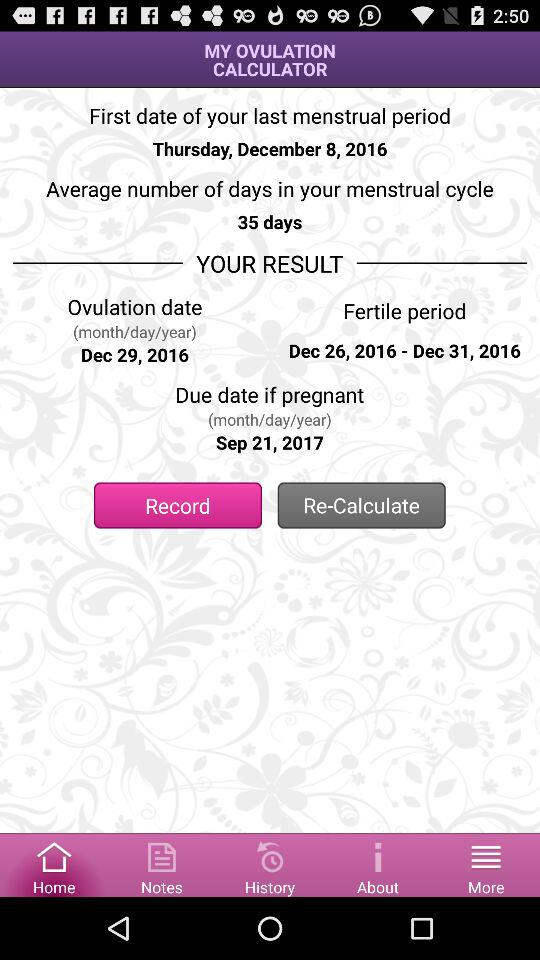What is the ovulation date? The ovulation date is December 29, 2016. 